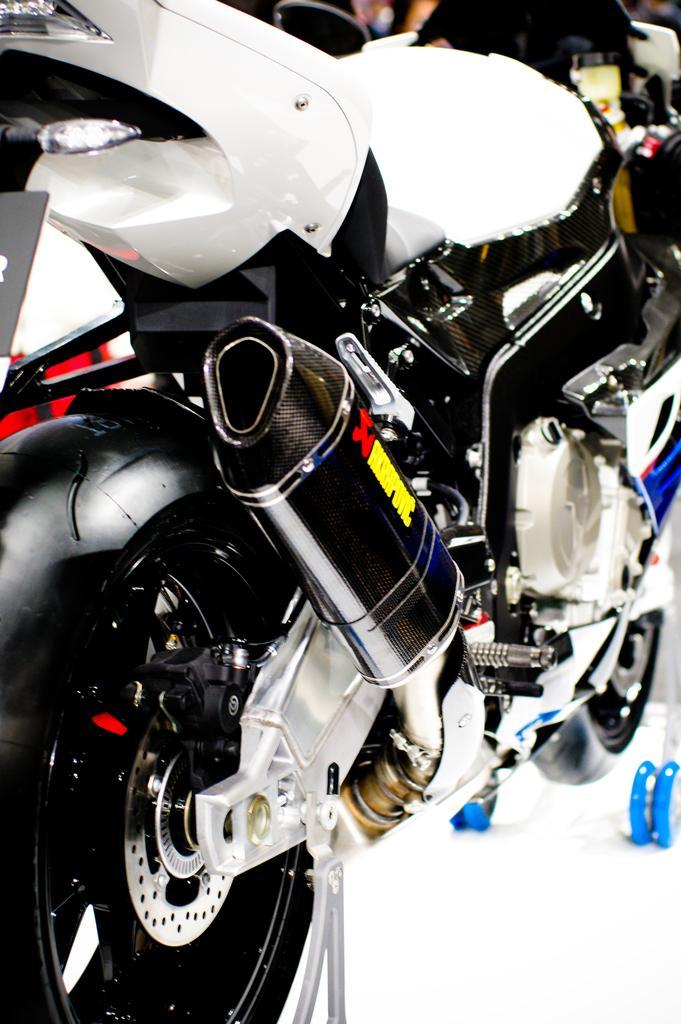Please provide a concise description of this image. In this picture we can see a motor bicycle. 